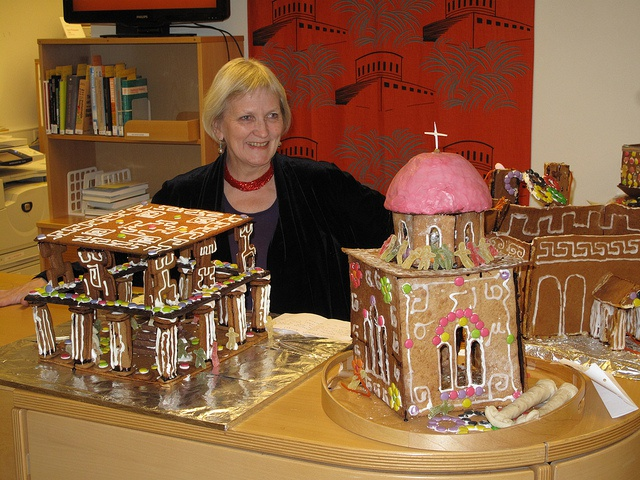Describe the objects in this image and their specific colors. I can see cake in olive, maroon, black, and brown tones, cake in olive, tan, brown, and lightpink tones, people in olive, black, gray, maroon, and tan tones, cake in olive, maroon, brown, and gray tones, and tv in olive, black, maroon, and gray tones in this image. 